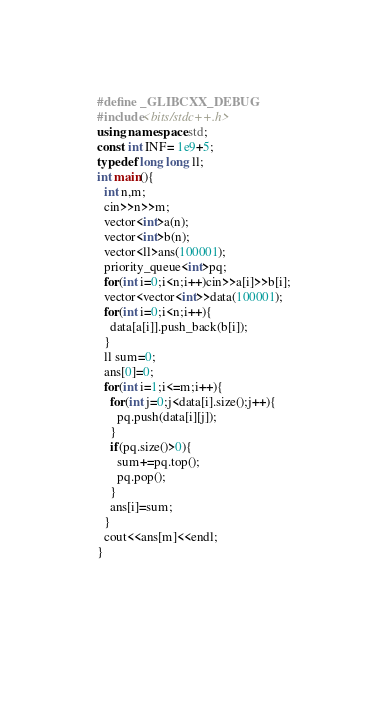Convert code to text. <code><loc_0><loc_0><loc_500><loc_500><_C++_>#define _GLIBCXX_DEBUG
#include<bits/stdc++.h>
using namespace std;
const int INF= 1e9+5;
typedef long long ll;
int main(){
  int n,m;
  cin>>n>>m;
  vector<int>a(n);
  vector<int>b(n);
  vector<ll>ans(100001);
  priority_queue<int>pq;
  for(int i=0;i<n;i++)cin>>a[i]>>b[i];
  vector<vector<int>>data(100001);
  for(int i=0;i<n;i++){
    data[a[i]].push_back(b[i]);
  }
  ll sum=0;
  ans[0]=0;
  for(int i=1;i<=m;i++){
    for(int j=0;j<data[i].size();j++){
      pq.push(data[i][j]);
    }
    if(pq.size()>0){
      sum+=pq.top();
      pq.pop();
    }
    ans[i]=sum;
  }
  cout<<ans[m]<<endl;
}
      
  
  
</code> 